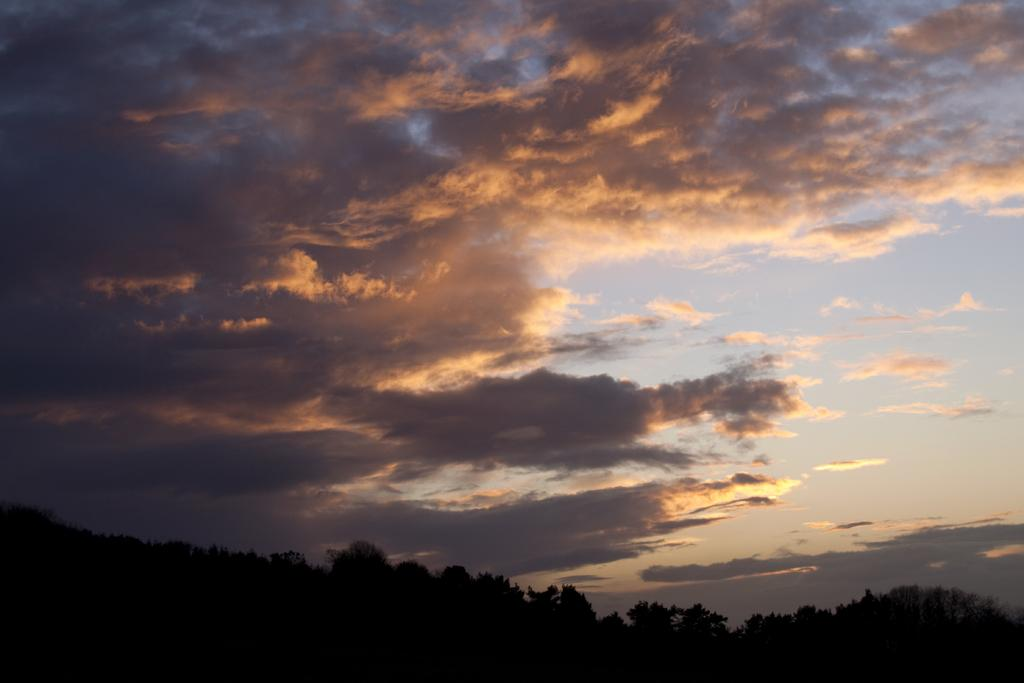What type of vegetation is at the bottom of the image? There are trees at the bottom of the image. What is visible in the upper part of the image? The sky is visible in the image. What can be seen in the sky? Clouds are present in the sky. Is the maid holding a dog in the image? There is no maid or dog present in the image. What time of day is depicted in the image? The provided facts do not give any information about the time of day, so it cannot be determined from the image. 